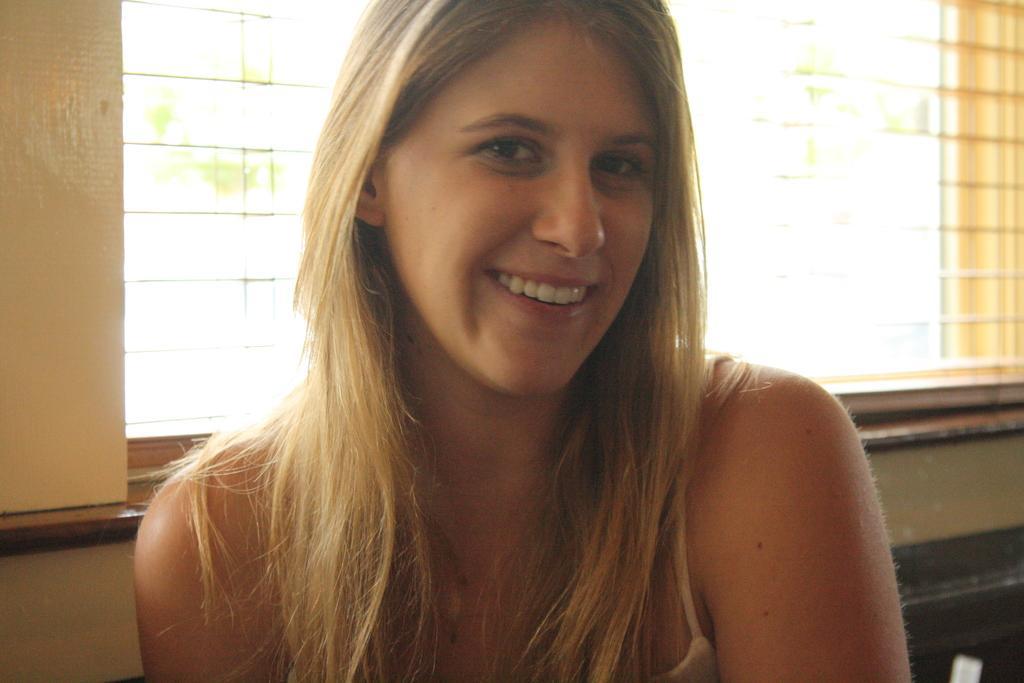Describe this image in one or two sentences. In this picture I can observe a woman in the middle of the picture. She is smiling. In the background I can observe a window. 